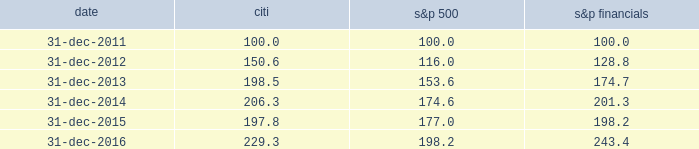Performance graph comparison of five-year cumulative total return the following graph and table compare the cumulative total return on citi 2019s common stock , which is listed on the nyse under the ticker symbol 201cc 201d and held by 77787 common stockholders of record as of january 31 , 2017 , with the cumulative total return of the s&p 500 index and the s&p financial index over the five-year period through december 31 , 2016 .
The graph and table assume that $ 100 was invested on december 31 , 2011 in citi 2019s common stock , the s&p 500 index and the s&p financial index , and that all dividends were reinvested .
Comparison of five-year cumulative total return for the years ended date citi s&p 500 financials .

What was the percentage cumulative total return for citi common stock for the five years ended december 31 , 2016? 
Computations: ((229.3 - 100) / 100)
Answer: 1.293. 